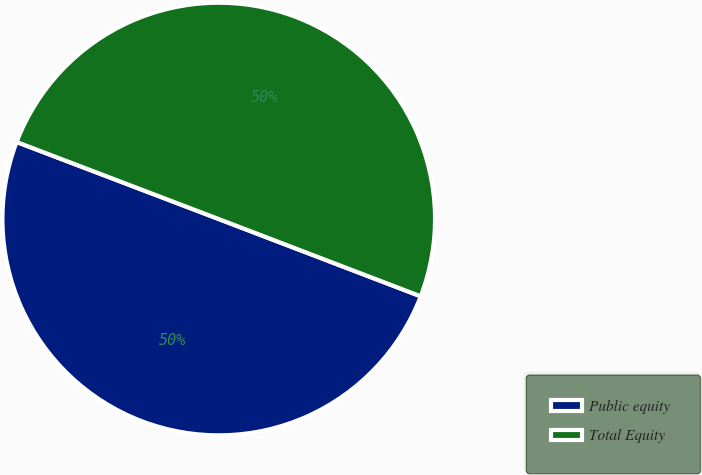Convert chart. <chart><loc_0><loc_0><loc_500><loc_500><pie_chart><fcel>Public equity<fcel>Total Equity<nl><fcel>49.98%<fcel>50.02%<nl></chart> 